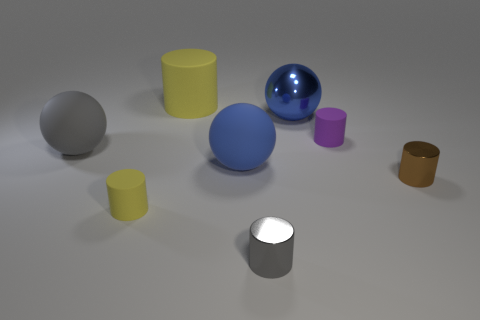What is the material of the gray object that is in front of the brown metal object?
Provide a short and direct response. Metal. There is a purple object that is made of the same material as the large cylinder; what size is it?
Give a very brief answer. Small. There is a large gray rubber object; are there any brown metal objects on the right side of it?
Make the answer very short. Yes. There is a purple object that is the same shape as the brown object; what is its size?
Ensure brevity in your answer.  Small. Does the metal sphere have the same color as the matte sphere that is to the right of the small yellow rubber cylinder?
Offer a very short reply. Yes. Is the large rubber cylinder the same color as the big shiny thing?
Provide a short and direct response. No. Is the number of small yellow matte things less than the number of cyan cubes?
Offer a very short reply. No. How many other objects are there of the same color as the big shiny sphere?
Make the answer very short. 1. How many small yellow things are there?
Provide a succinct answer. 1. Are there fewer yellow cylinders behind the big metal ball than small purple matte cylinders?
Provide a succinct answer. No. 